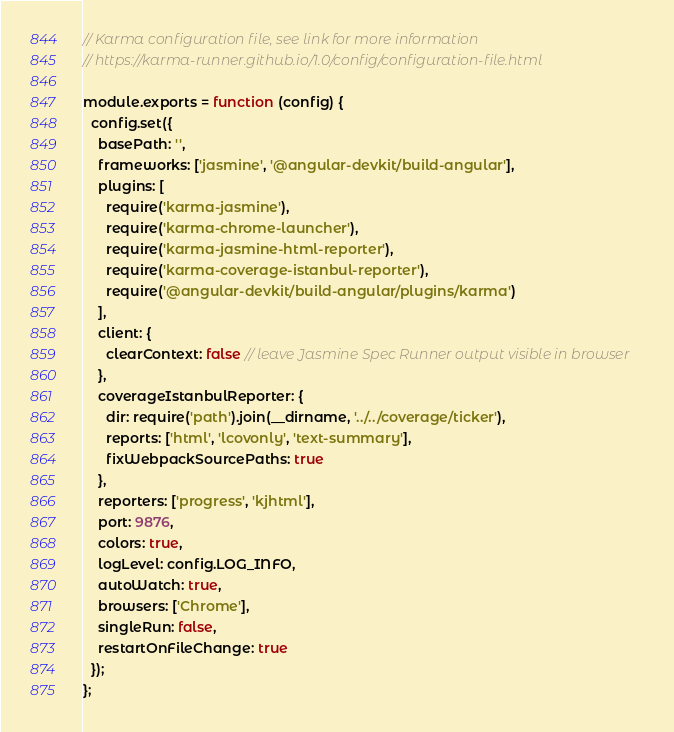<code> <loc_0><loc_0><loc_500><loc_500><_JavaScript_>// Karma configuration file, see link for more information
// https://karma-runner.github.io/1.0/config/configuration-file.html

module.exports = function (config) {
  config.set({
    basePath: '',
    frameworks: ['jasmine', '@angular-devkit/build-angular'],
    plugins: [
      require('karma-jasmine'),
      require('karma-chrome-launcher'),
      require('karma-jasmine-html-reporter'),
      require('karma-coverage-istanbul-reporter'),
      require('@angular-devkit/build-angular/plugins/karma')
    ],
    client: {
      clearContext: false // leave Jasmine Spec Runner output visible in browser
    },
    coverageIstanbulReporter: {
      dir: require('path').join(__dirname, '../../coverage/ticker'),
      reports: ['html', 'lcovonly', 'text-summary'],
      fixWebpackSourcePaths: true
    },
    reporters: ['progress', 'kjhtml'],
    port: 9876,
    colors: true,
    logLevel: config.LOG_INFO,
    autoWatch: true,
    browsers: ['Chrome'],
    singleRun: false,
    restartOnFileChange: true
  });
};
</code> 